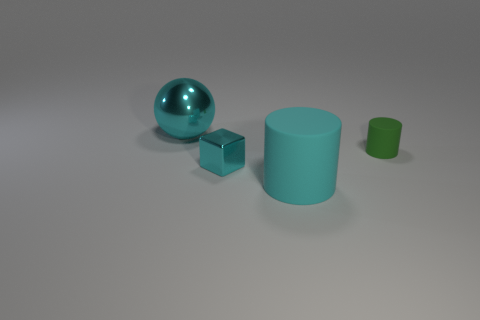There is a matte cylinder behind the big cyan rubber cylinder; what color is it?
Your response must be concise. Green. The object that is the same material as the cube is what shape?
Ensure brevity in your answer.  Sphere. Is there any other thing of the same color as the large ball?
Provide a short and direct response. Yes. Are there more cyan matte things that are on the left side of the small cyan shiny thing than cyan metal cubes that are on the left side of the metal sphere?
Provide a succinct answer. No. What number of shiny balls are the same size as the cyan rubber cylinder?
Your answer should be very brief. 1. Is the number of small cyan metal blocks in front of the large matte object less than the number of small green rubber cylinders to the left of the small green object?
Make the answer very short. No. Are there any other big cyan metallic objects that have the same shape as the big shiny thing?
Your answer should be compact. No. Do the small matte object and the large cyan shiny thing have the same shape?
Offer a very short reply. No. What number of large things are either cyan blocks or green rubber objects?
Give a very brief answer. 0. Are there more big cyan rubber cylinders than metal cylinders?
Your answer should be very brief. Yes. 